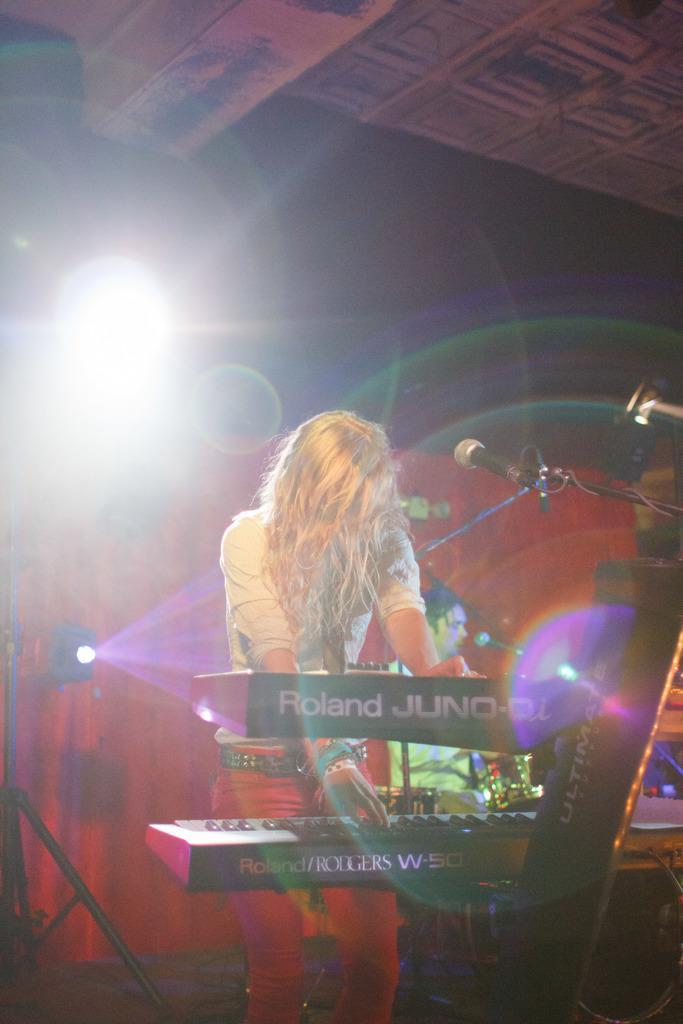How would you summarize this image in a sentence or two? In this image I can see two persons are playing musical instruments on the stage and a speaker stand. In the background I can see focus lights and a rooftop. This image is taken may be on the stage. 